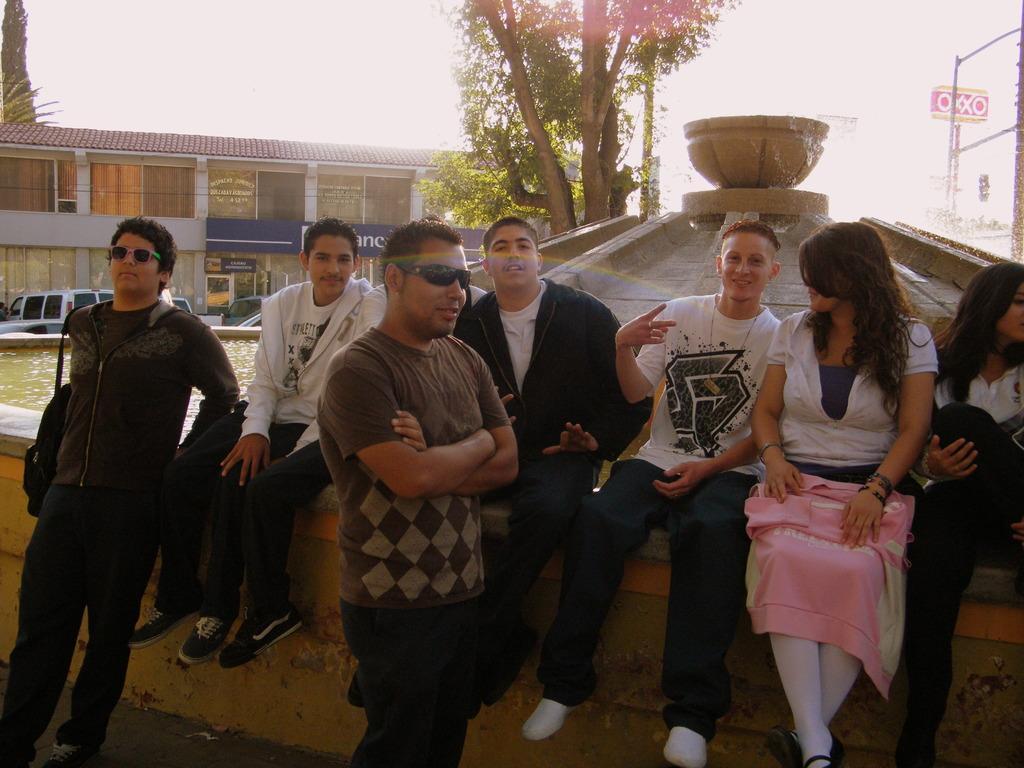Please provide a concise description of this image. In this image we can see group of people sitting on the wall. One person wearing goggles is standing.. In the background we can see several vehicles,building and group of plants and sky. 